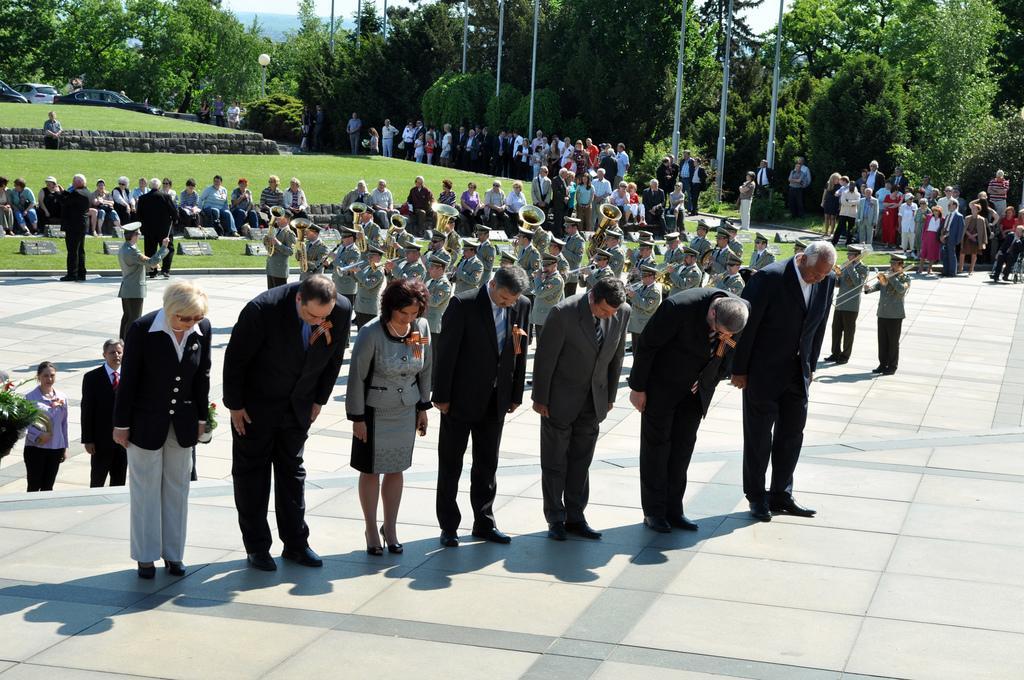Can you describe this image briefly? In this image I can see few people are standing, few people are sitting and few people are holding musical instruments. Back I can see few trees, poles and vehicles. 